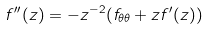<formula> <loc_0><loc_0><loc_500><loc_500>f ^ { \prime \prime } ( z ) = - z ^ { - 2 } ( f _ { \theta \theta } + z f ^ { \prime } ( z ) )</formula> 